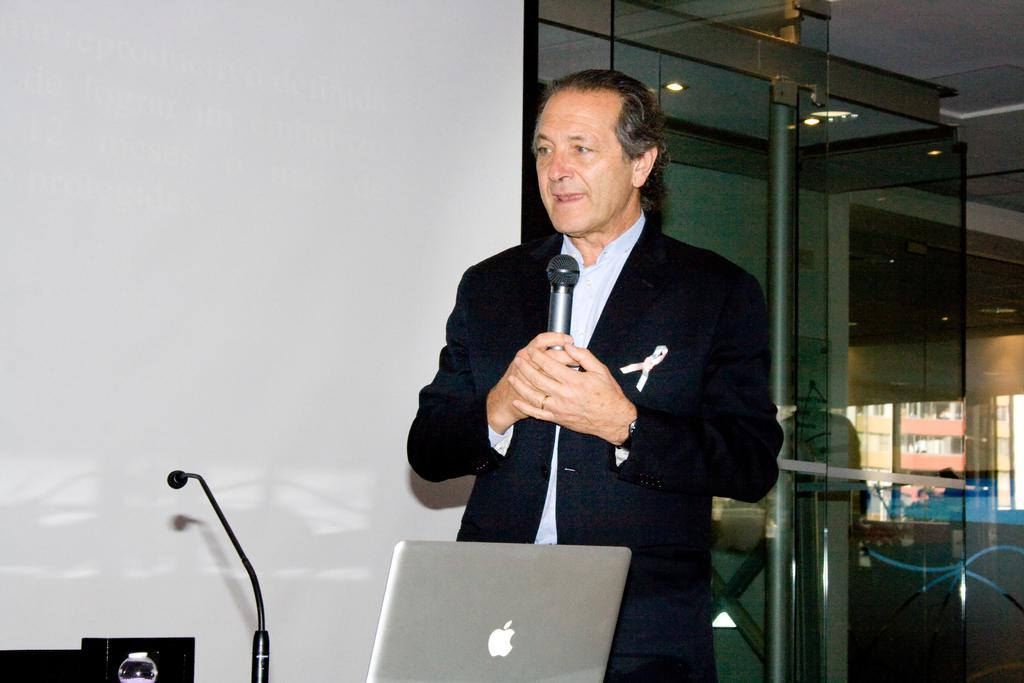What is the main subject of the image? The main subject of the image is a man. What is the man doing in the image? The man is standing and speaking in the image. What object is the man holding? The man is holding a microphone in the image. What other electronic device is present in the image? There is a laptop in the image. Are there any additional microphones in the image? Yes, there is another microphone in the image. What type of hen can be seen sitting on the laptop in the image? There is no hen present in the image; it features a man holding a microphone and standing near a laptop. 